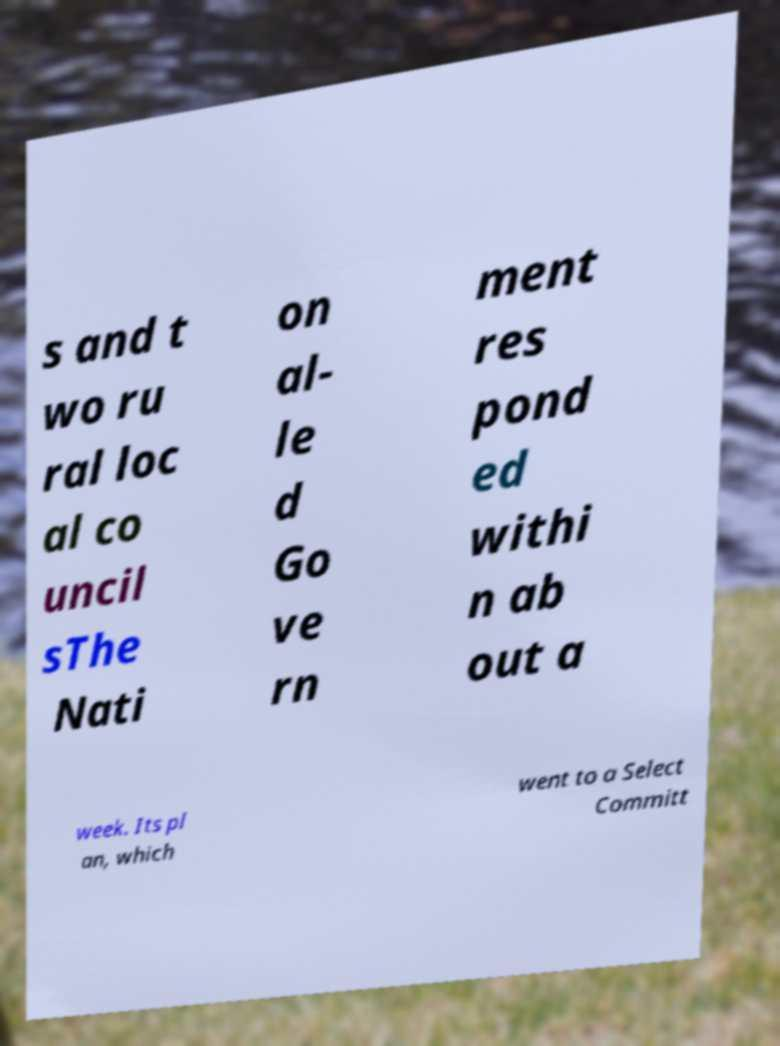Please identify and transcribe the text found in this image. s and t wo ru ral loc al co uncil sThe Nati on al- le d Go ve rn ment res pond ed withi n ab out a week. Its pl an, which went to a Select Committ 